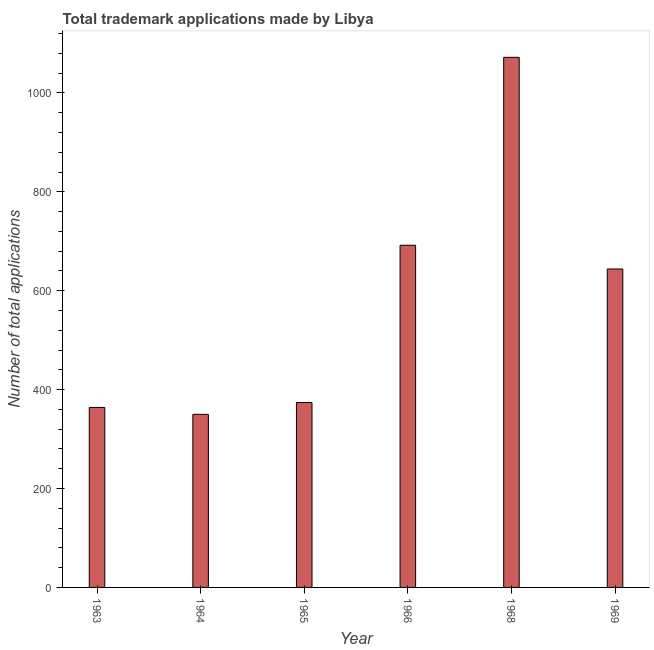Does the graph contain grids?
Provide a short and direct response. No. What is the title of the graph?
Ensure brevity in your answer.  Total trademark applications made by Libya. What is the label or title of the X-axis?
Give a very brief answer. Year. What is the label or title of the Y-axis?
Provide a succinct answer. Number of total applications. What is the number of trademark applications in 1963?
Your response must be concise. 364. Across all years, what is the maximum number of trademark applications?
Keep it short and to the point. 1072. Across all years, what is the minimum number of trademark applications?
Ensure brevity in your answer.  350. In which year was the number of trademark applications maximum?
Your response must be concise. 1968. In which year was the number of trademark applications minimum?
Make the answer very short. 1964. What is the sum of the number of trademark applications?
Give a very brief answer. 3496. What is the difference between the number of trademark applications in 1964 and 1968?
Offer a terse response. -722. What is the average number of trademark applications per year?
Provide a short and direct response. 582. What is the median number of trademark applications?
Your answer should be compact. 509. Do a majority of the years between 1964 and 1968 (inclusive) have number of trademark applications greater than 200 ?
Give a very brief answer. Yes. What is the ratio of the number of trademark applications in 1964 to that in 1968?
Provide a short and direct response. 0.33. Is the number of trademark applications in 1965 less than that in 1968?
Provide a short and direct response. Yes. What is the difference between the highest and the second highest number of trademark applications?
Your response must be concise. 380. Is the sum of the number of trademark applications in 1965 and 1968 greater than the maximum number of trademark applications across all years?
Your answer should be compact. Yes. What is the difference between the highest and the lowest number of trademark applications?
Provide a short and direct response. 722. How many years are there in the graph?
Make the answer very short. 6. What is the Number of total applications of 1963?
Your answer should be very brief. 364. What is the Number of total applications of 1964?
Provide a short and direct response. 350. What is the Number of total applications in 1965?
Provide a short and direct response. 374. What is the Number of total applications of 1966?
Offer a very short reply. 692. What is the Number of total applications of 1968?
Your response must be concise. 1072. What is the Number of total applications of 1969?
Offer a very short reply. 644. What is the difference between the Number of total applications in 1963 and 1964?
Your answer should be very brief. 14. What is the difference between the Number of total applications in 1963 and 1965?
Give a very brief answer. -10. What is the difference between the Number of total applications in 1963 and 1966?
Offer a terse response. -328. What is the difference between the Number of total applications in 1963 and 1968?
Your answer should be very brief. -708. What is the difference between the Number of total applications in 1963 and 1969?
Offer a terse response. -280. What is the difference between the Number of total applications in 1964 and 1966?
Your response must be concise. -342. What is the difference between the Number of total applications in 1964 and 1968?
Your answer should be very brief. -722. What is the difference between the Number of total applications in 1964 and 1969?
Provide a short and direct response. -294. What is the difference between the Number of total applications in 1965 and 1966?
Your answer should be compact. -318. What is the difference between the Number of total applications in 1965 and 1968?
Your answer should be compact. -698. What is the difference between the Number of total applications in 1965 and 1969?
Offer a very short reply. -270. What is the difference between the Number of total applications in 1966 and 1968?
Offer a terse response. -380. What is the difference between the Number of total applications in 1968 and 1969?
Give a very brief answer. 428. What is the ratio of the Number of total applications in 1963 to that in 1966?
Keep it short and to the point. 0.53. What is the ratio of the Number of total applications in 1963 to that in 1968?
Keep it short and to the point. 0.34. What is the ratio of the Number of total applications in 1963 to that in 1969?
Offer a very short reply. 0.56. What is the ratio of the Number of total applications in 1964 to that in 1965?
Provide a succinct answer. 0.94. What is the ratio of the Number of total applications in 1964 to that in 1966?
Make the answer very short. 0.51. What is the ratio of the Number of total applications in 1964 to that in 1968?
Offer a terse response. 0.33. What is the ratio of the Number of total applications in 1964 to that in 1969?
Make the answer very short. 0.54. What is the ratio of the Number of total applications in 1965 to that in 1966?
Make the answer very short. 0.54. What is the ratio of the Number of total applications in 1965 to that in 1968?
Give a very brief answer. 0.35. What is the ratio of the Number of total applications in 1965 to that in 1969?
Give a very brief answer. 0.58. What is the ratio of the Number of total applications in 1966 to that in 1968?
Ensure brevity in your answer.  0.65. What is the ratio of the Number of total applications in 1966 to that in 1969?
Your answer should be compact. 1.07. What is the ratio of the Number of total applications in 1968 to that in 1969?
Keep it short and to the point. 1.67. 